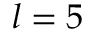Convert formula to latex. <formula><loc_0><loc_0><loc_500><loc_500>l = 5</formula> 